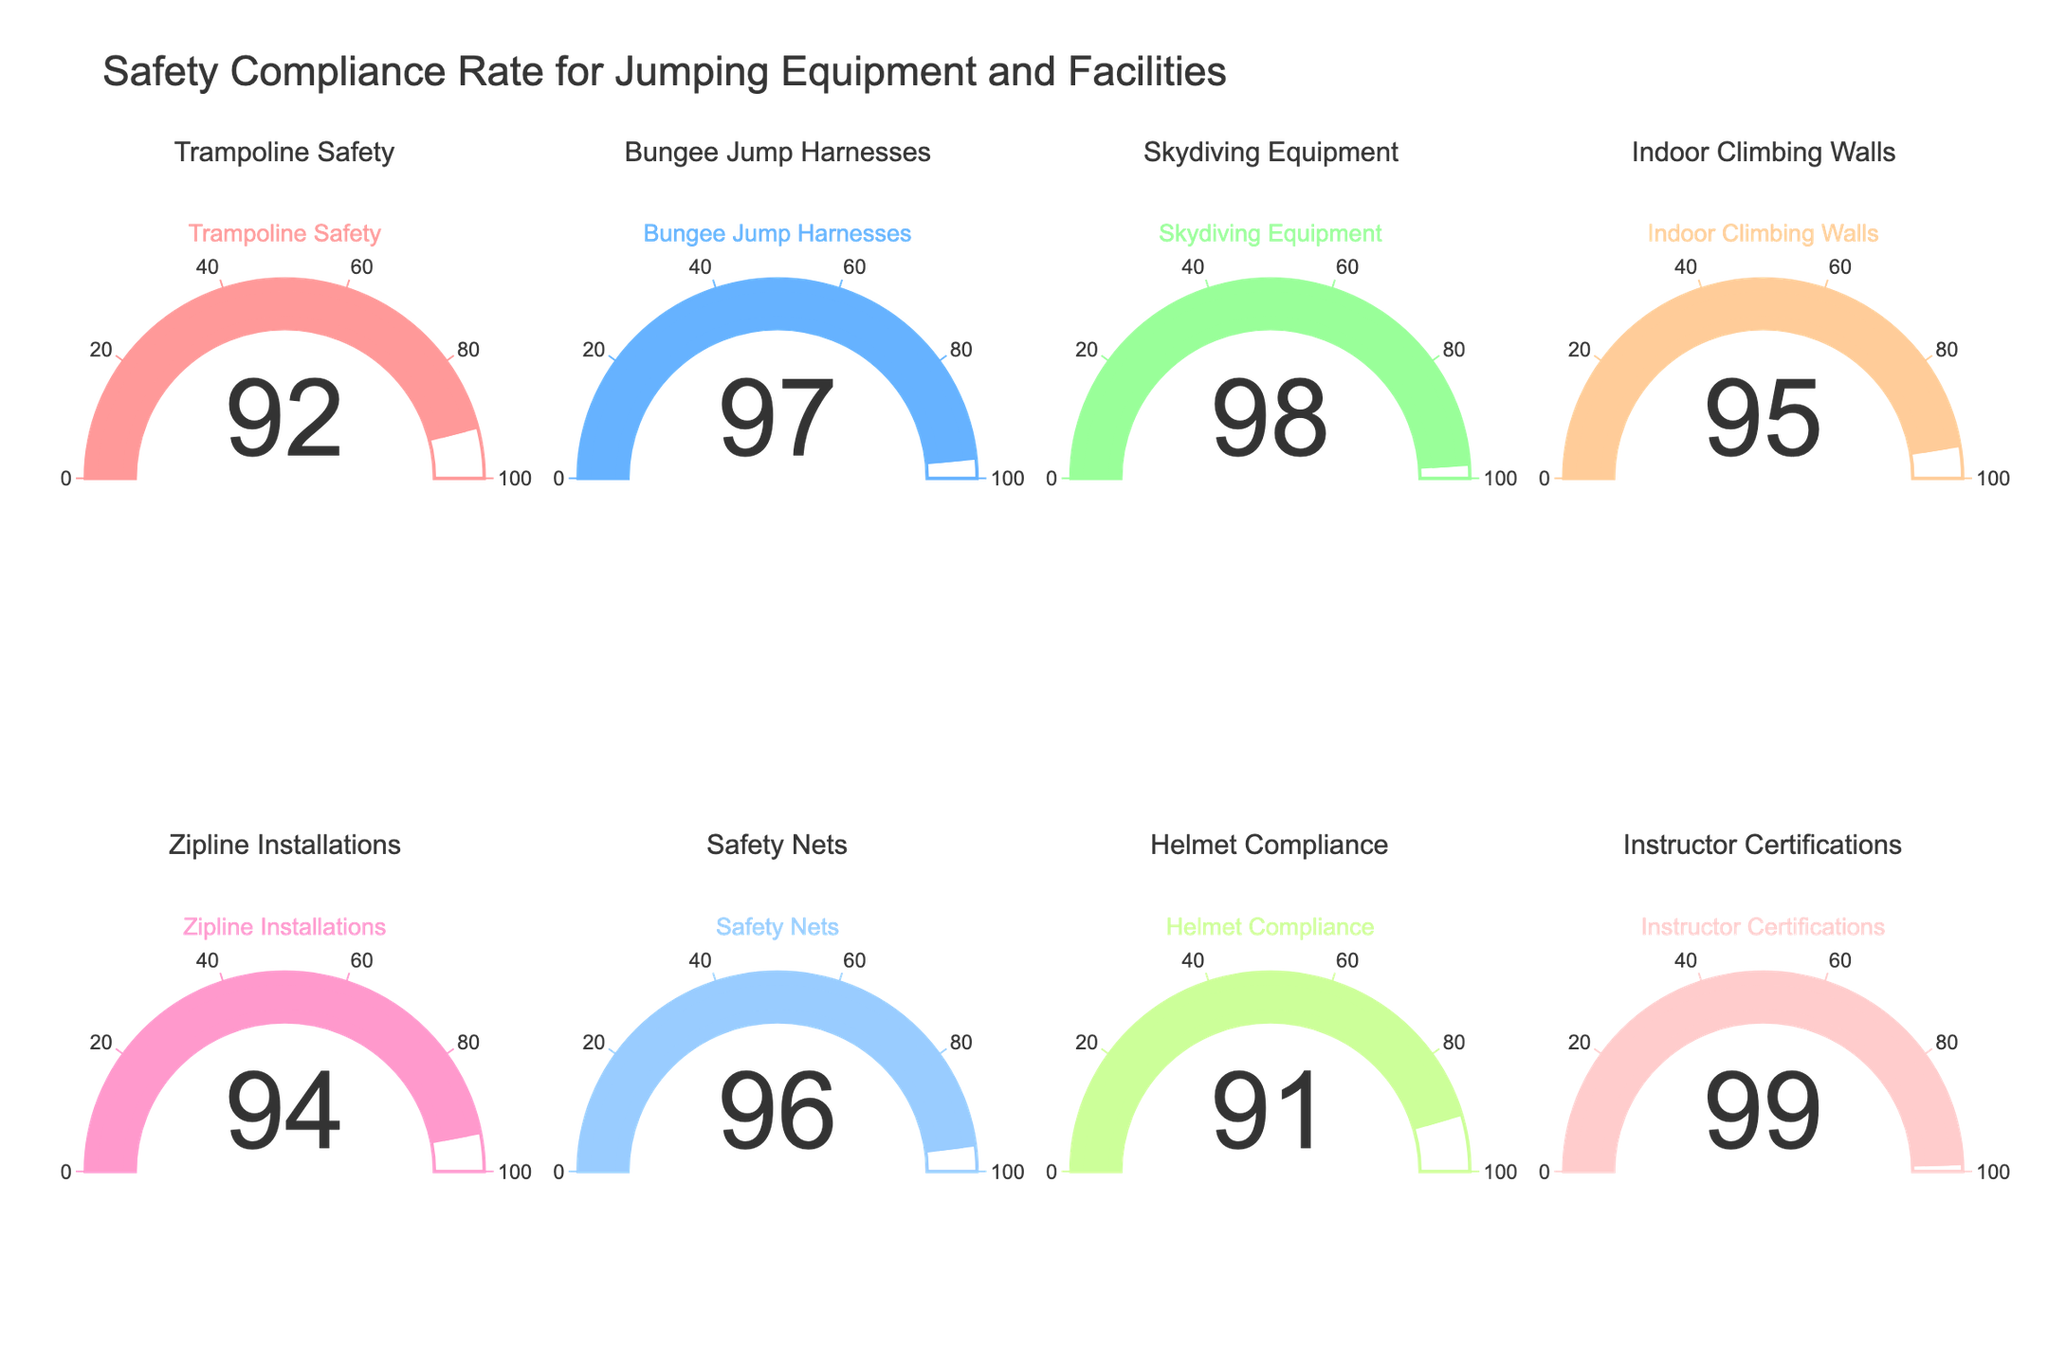What is the title of the figure? The title of the figure is usually prominently displayed and provides the context of the visual data. Reading it helps understand the main focus of the chart.
Answer: Safety Compliance Rate for Jumping Equipment and Facilities Which category has the highest safety compliance rate? By looking at the numeric value displayed on each gauge, the highest number identifies the category with the highest compliance rate.
Answer: Instructor Certifications What is the compliance rate for Helmet Compliance? Locate the gauge for Helmet Compliance and read the number displayed in the center of the gauge.
Answer: 91 Which category has the lowest safety compliance rate? Compare the values on all gauges; the lowest number indicates the category with the lowest compliance rate.
Answer: Helmet Compliance How many categories have a compliance rate of 95 or higher? Count the gauges showing 95 or above by examining each value displayed on the gauges.
Answer: 6 What is the average compliance rate across all categories? Sum the values of all compliance rates and divide by the total number of categories. The values are: 92, 97, 98, 95, 94, 96, 91, 99. The total sum is 92 + 97 + 98 + 95 + 94 + 96 + 91 + 99 = 762. There are 8 categories, so the average is 762 / 8 = 95.25.
Answer: 95.25 Which categories have a compliance rate less than 95? Identify and list the categories with values below 95 by examining each gauge.
Answer: Trampoline Safety, Zipline Installations, Helmet Compliance What is the difference between the compliance rate of Skydiving Equipment and Safety Nets? Subtract the compliance rate of Safety Nets from the compliance rate of Skydiving Equipment. The values are 98 and 96, respectively. 98 - 96 = 2.
Answer: 2 How much higher is the compliance rate for Indoor Climbing Walls compared to Trampoline Safety? Subtract the compliance rate of Trampoline Safety from the compliance rate of Indoor Climbing Walls. The values are 95 and 92, respectively. 95 - 92 = 3.
Answer: 3 Is there any category with a compliance rate equal to 94? Check each gauge for the value 94. If any gauge displays this value, the answer is yes; otherwise, no. The value 94 is shown by Zipline Installations.
Answer: Yes What is the second highest safety compliance rate? Identify the second-largest number among the displayed values. The highest is 99 (Instructor Certifications), so the second highest is 98 (Skydiving Equipment).
Answer: 98 